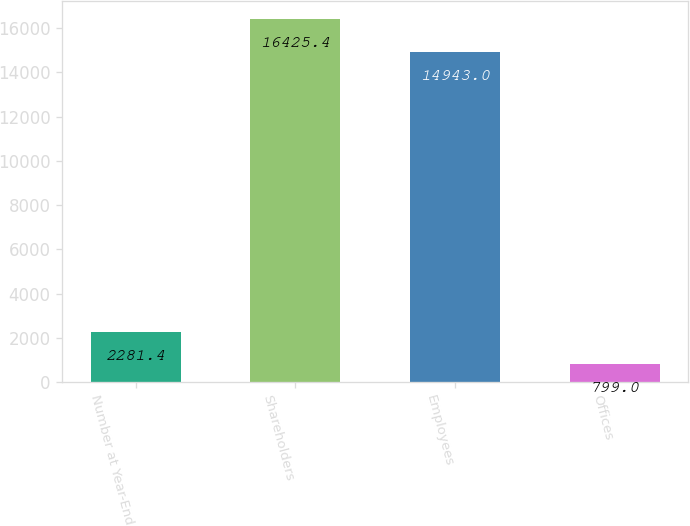Convert chart to OTSL. <chart><loc_0><loc_0><loc_500><loc_500><bar_chart><fcel>Number at Year-End<fcel>Shareholders<fcel>Employees<fcel>Offices<nl><fcel>2281.4<fcel>16425.4<fcel>14943<fcel>799<nl></chart> 